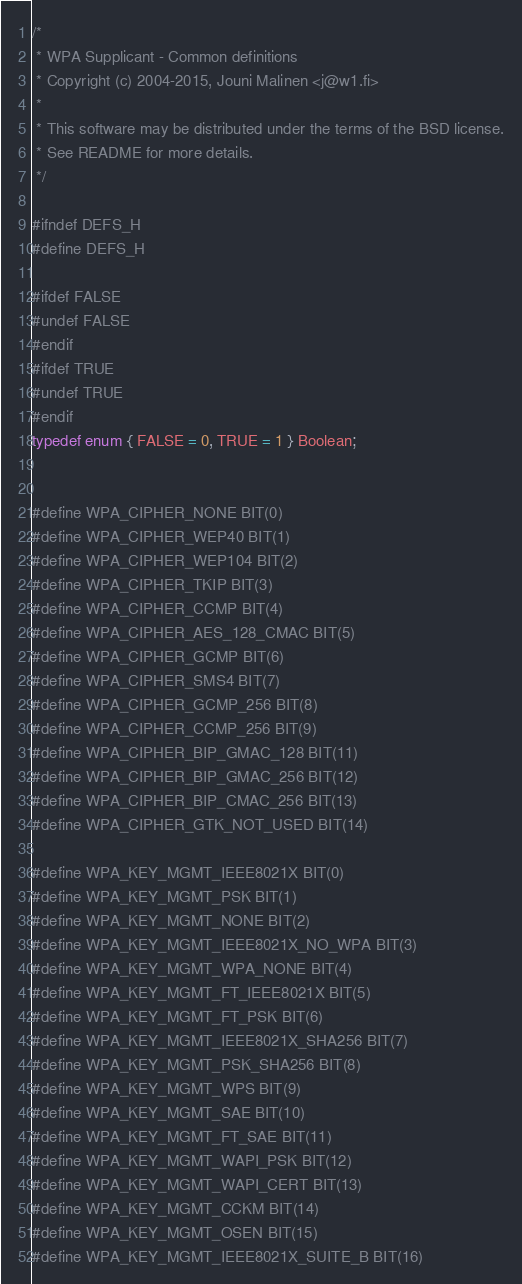<code> <loc_0><loc_0><loc_500><loc_500><_C_>/*
 * WPA Supplicant - Common definitions
 * Copyright (c) 2004-2015, Jouni Malinen <j@w1.fi>
 *
 * This software may be distributed under the terms of the BSD license.
 * See README for more details.
 */

#ifndef DEFS_H
#define DEFS_H

#ifdef FALSE
#undef FALSE
#endif
#ifdef TRUE
#undef TRUE
#endif
typedef enum { FALSE = 0, TRUE = 1 } Boolean;


#define WPA_CIPHER_NONE BIT(0)
#define WPA_CIPHER_WEP40 BIT(1)
#define WPA_CIPHER_WEP104 BIT(2)
#define WPA_CIPHER_TKIP BIT(3)
#define WPA_CIPHER_CCMP BIT(4)
#define WPA_CIPHER_AES_128_CMAC BIT(5)
#define WPA_CIPHER_GCMP BIT(6)
#define WPA_CIPHER_SMS4 BIT(7)
#define WPA_CIPHER_GCMP_256 BIT(8)
#define WPA_CIPHER_CCMP_256 BIT(9)
#define WPA_CIPHER_BIP_GMAC_128 BIT(11)
#define WPA_CIPHER_BIP_GMAC_256 BIT(12)
#define WPA_CIPHER_BIP_CMAC_256 BIT(13)
#define WPA_CIPHER_GTK_NOT_USED BIT(14)

#define WPA_KEY_MGMT_IEEE8021X BIT(0)
#define WPA_KEY_MGMT_PSK BIT(1)
#define WPA_KEY_MGMT_NONE BIT(2)
#define WPA_KEY_MGMT_IEEE8021X_NO_WPA BIT(3)
#define WPA_KEY_MGMT_WPA_NONE BIT(4)
#define WPA_KEY_MGMT_FT_IEEE8021X BIT(5)
#define WPA_KEY_MGMT_FT_PSK BIT(6)
#define WPA_KEY_MGMT_IEEE8021X_SHA256 BIT(7)
#define WPA_KEY_MGMT_PSK_SHA256 BIT(8)
#define WPA_KEY_MGMT_WPS BIT(9)
#define WPA_KEY_MGMT_SAE BIT(10)
#define WPA_KEY_MGMT_FT_SAE BIT(11)
#define WPA_KEY_MGMT_WAPI_PSK BIT(12)
#define WPA_KEY_MGMT_WAPI_CERT BIT(13)
#define WPA_KEY_MGMT_CCKM BIT(14)
#define WPA_KEY_MGMT_OSEN BIT(15)
#define WPA_KEY_MGMT_IEEE8021X_SUITE_B BIT(16)</code> 